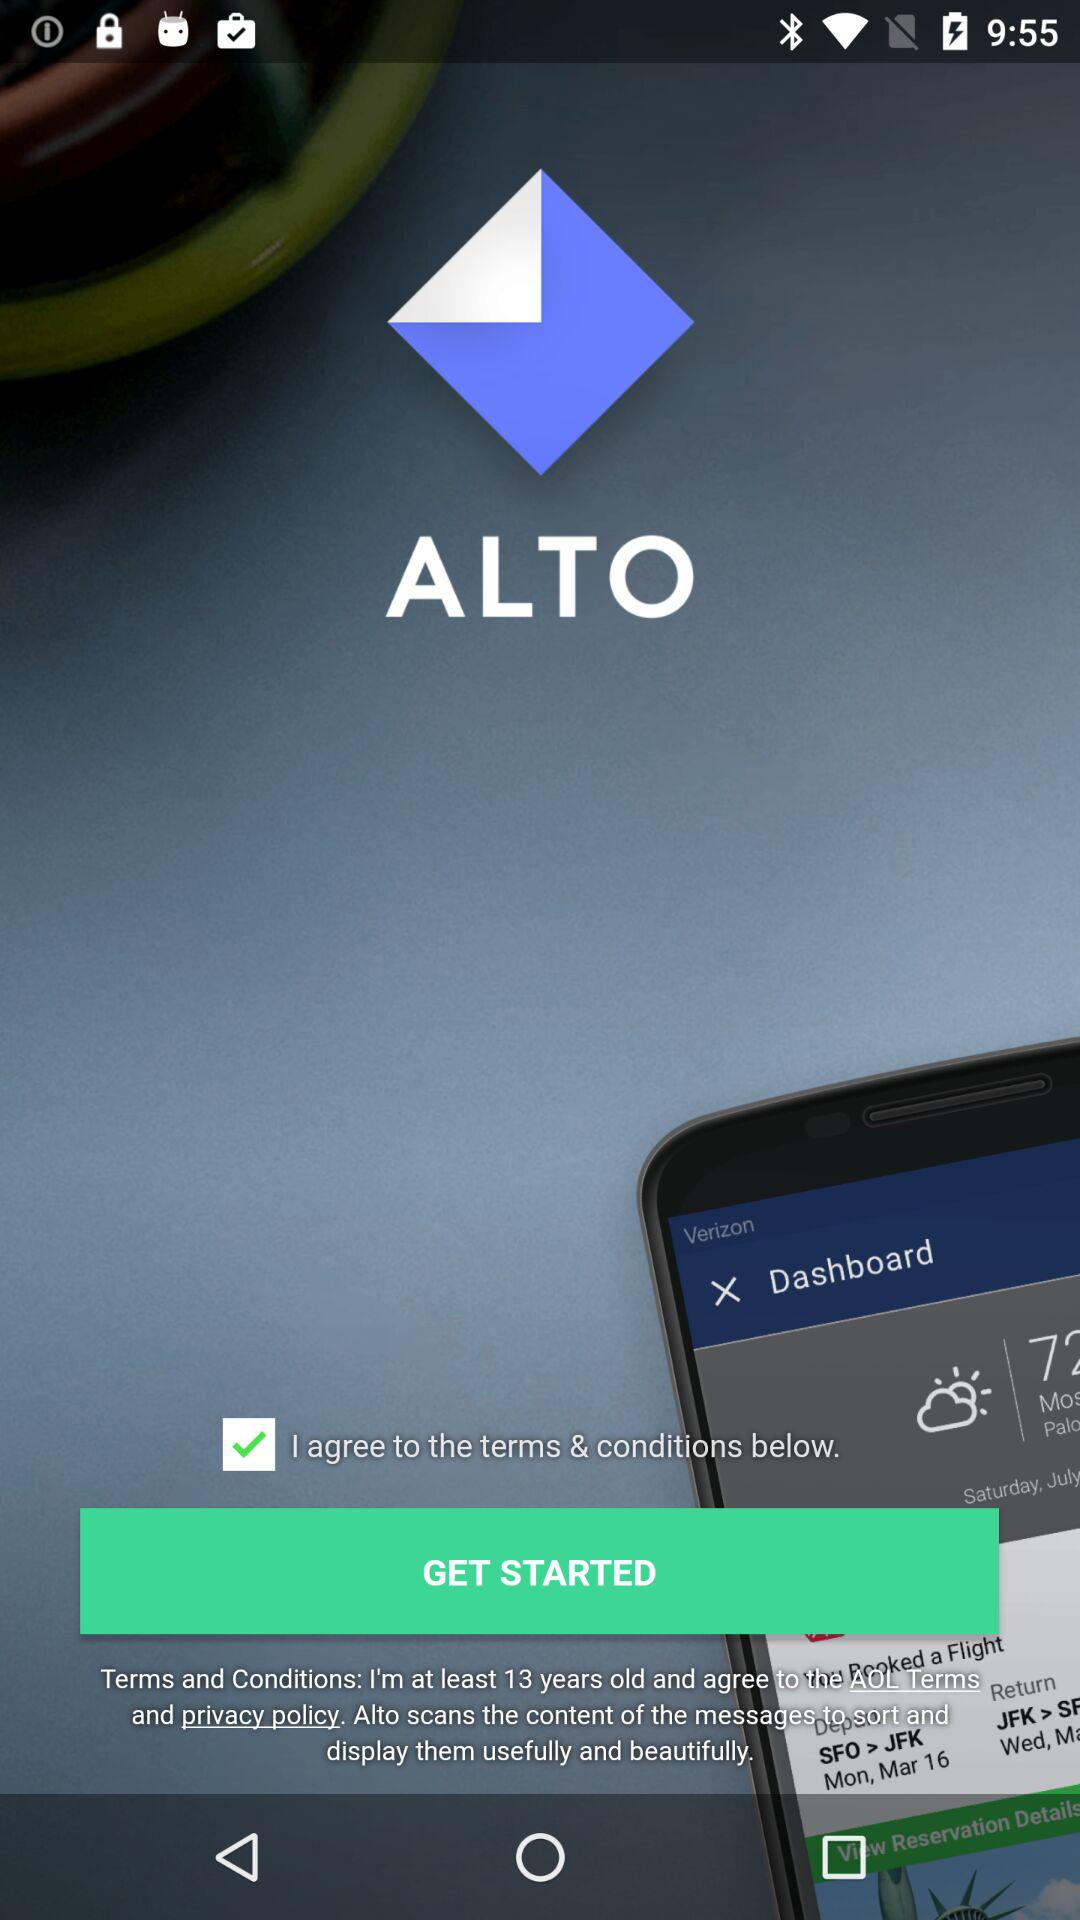What is the status of the option that includes agreement to the "terms and conditions"? The status of the option that includes agreement to the "terms and conditions" is "on". 